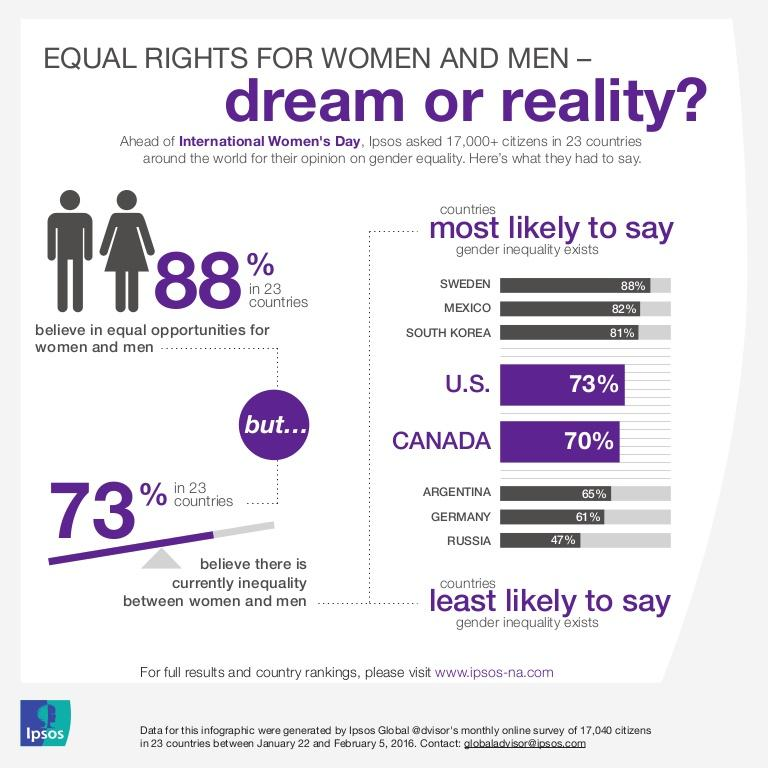Give some essential details in this illustration. According to the survey, only a small percentage of respondents from Sweden, Mexico, and South Korea believe that inequality does not exist. According to the survey, in the country with the lowest percentage of respondents who believe that inequality exists, Russia has less than 50% of individuals who hold this belief. 